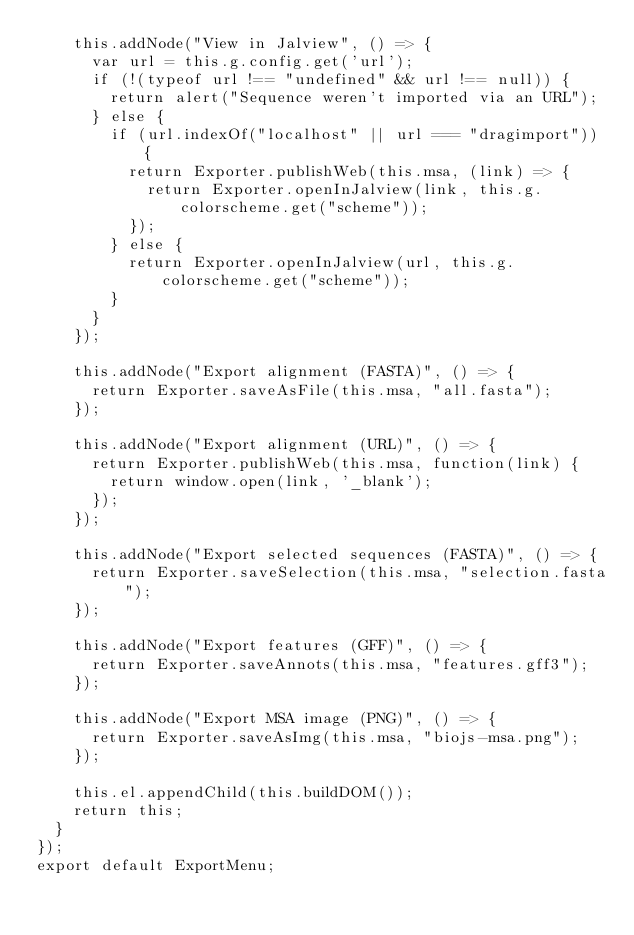Convert code to text. <code><loc_0><loc_0><loc_500><loc_500><_JavaScript_>    this.addNode("View in Jalview", () => {
      var url = this.g.config.get('url');
      if (!(typeof url !== "undefined" && url !== null)) {
        return alert("Sequence weren't imported via an URL");
      } else {
        if (url.indexOf("localhost" || url === "dragimport")) {
          return Exporter.publishWeb(this.msa, (link) => {
            return Exporter.openInJalview(link, this.g.colorscheme.get("scheme"));
          });
        } else {
          return Exporter.openInJalview(url, this.g.colorscheme.get("scheme"));
        }
      }
    });

    this.addNode("Export alignment (FASTA)", () => {
      return Exporter.saveAsFile(this.msa, "all.fasta");
    });

    this.addNode("Export alignment (URL)", () => {
      return Exporter.publishWeb(this.msa, function(link) {
        return window.open(link, '_blank');
      });
    });

    this.addNode("Export selected sequences (FASTA)", () => {
      return Exporter.saveSelection(this.msa, "selection.fasta");
    });

    this.addNode("Export features (GFF)", () => {
      return Exporter.saveAnnots(this.msa, "features.gff3");
    });

    this.addNode("Export MSA image (PNG)", () => {
      return Exporter.saveAsImg(this.msa, "biojs-msa.png");
    });

    this.el.appendChild(this.buildDOM());
    return this;
  }
});
export default ExportMenu;
</code> 